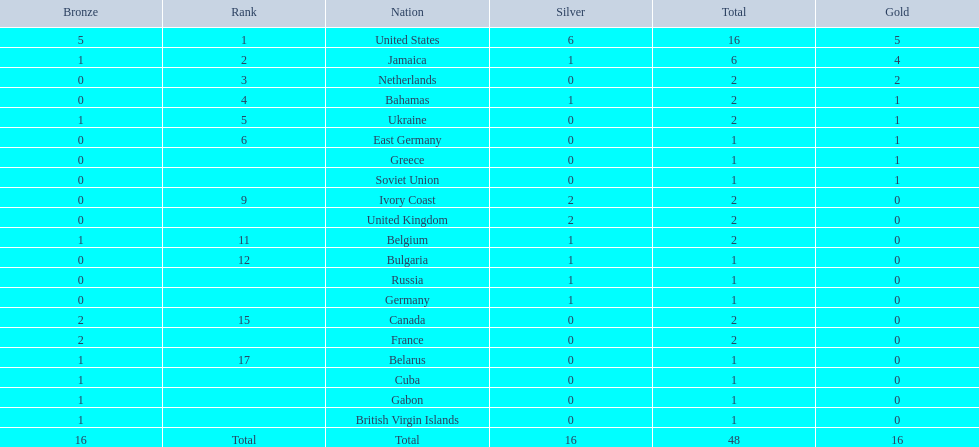I'm looking to parse the entire table for insights. Could you assist me with that? {'header': ['Bronze', 'Rank', 'Nation', 'Silver', 'Total', 'Gold'], 'rows': [['5', '1', 'United States', '6', '16', '5'], ['1', '2', 'Jamaica', '1', '6', '4'], ['0', '3', 'Netherlands', '0', '2', '2'], ['0', '4', 'Bahamas', '1', '2', '1'], ['1', '5', 'Ukraine', '0', '2', '1'], ['0', '6', 'East Germany', '0', '1', '1'], ['0', '', 'Greece', '0', '1', '1'], ['0', '', 'Soviet Union', '0', '1', '1'], ['0', '9', 'Ivory Coast', '2', '2', '0'], ['0', '', 'United Kingdom', '2', '2', '0'], ['1', '11', 'Belgium', '1', '2', '0'], ['0', '12', 'Bulgaria', '1', '1', '0'], ['0', '', 'Russia', '1', '1', '0'], ['0', '', 'Germany', '1', '1', '0'], ['2', '15', 'Canada', '0', '2', '0'], ['2', '', 'France', '0', '2', '0'], ['1', '17', 'Belarus', '0', '1', '0'], ['1', '', 'Cuba', '0', '1', '0'], ['1', '', 'Gabon', '0', '1', '0'], ['1', '', 'British Virgin Islands', '0', '1', '0'], ['16', 'Total', 'Total', '16', '48', '16']]} What is the cumulative number of gold medals that jamaica has achieved? 4. 